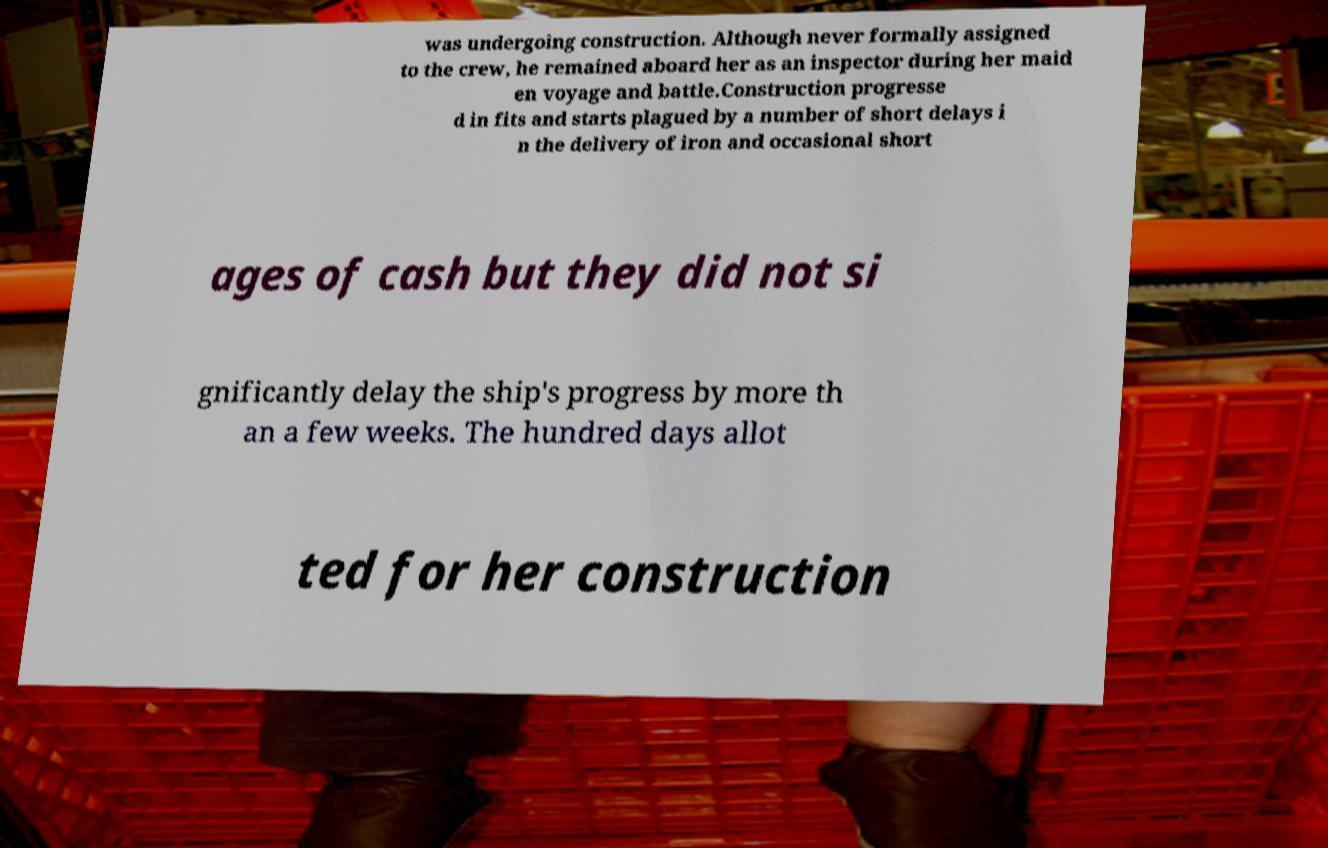Could you extract and type out the text from this image? was undergoing construction. Although never formally assigned to the crew, he remained aboard her as an inspector during her maid en voyage and battle.Construction progresse d in fits and starts plagued by a number of short delays i n the delivery of iron and occasional short ages of cash but they did not si gnificantly delay the ship's progress by more th an a few weeks. The hundred days allot ted for her construction 